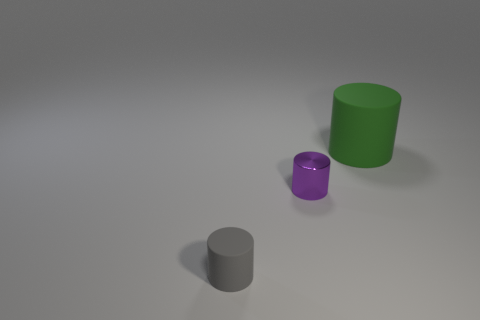What is the size of the shiny object behind the tiny rubber thing?
Ensure brevity in your answer.  Small. What number of other things are there of the same material as the large cylinder
Ensure brevity in your answer.  1. Are there more small purple metallic objects than small objects?
Offer a terse response. No. There is a matte thing behind the tiny metal cylinder; does it have the same color as the small matte cylinder?
Give a very brief answer. No. What is the color of the big object?
Provide a short and direct response. Green. Are there any tiny purple objects on the left side of the tiny object right of the small gray cylinder?
Your answer should be compact. No. There is a matte thing that is left of the rubber object on the right side of the tiny shiny cylinder; what shape is it?
Offer a very short reply. Cylinder. Are there fewer small rubber objects than cylinders?
Your answer should be compact. Yes. Is the material of the green cylinder the same as the gray cylinder?
Offer a terse response. Yes. What color is the cylinder that is both behind the small gray rubber object and in front of the green cylinder?
Offer a very short reply. Purple. 